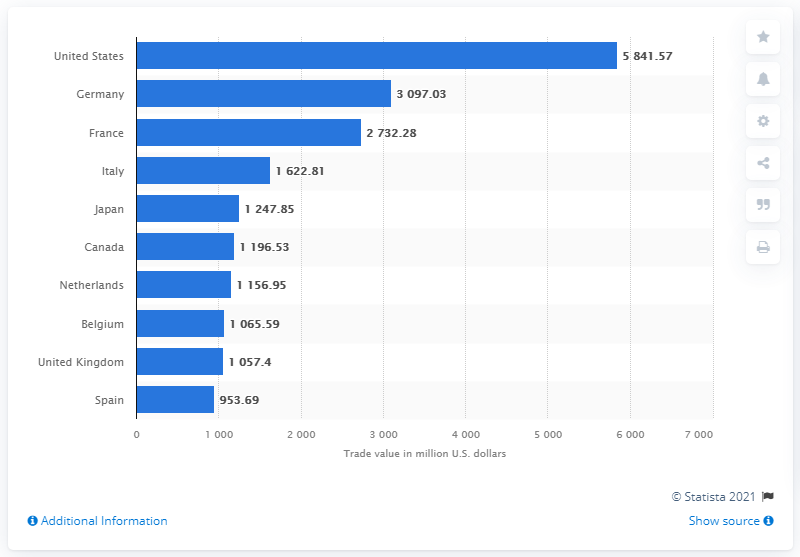List a handful of essential elements in this visual. In 2019, Germany was the second largest importer of coffee in the world. In 2019, the United States imported 58,41.57 metric tons of coffee. 